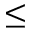Convert formula to latex. <formula><loc_0><loc_0><loc_500><loc_500>\leq</formula> 